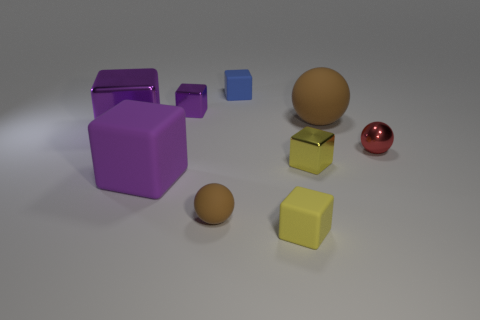What is the color of the metal ball?
Offer a very short reply. Red. There is a small block that is the same color as the big metallic thing; what is it made of?
Ensure brevity in your answer.  Metal. What is the material of the thing that is on the right side of the big matte ball?
Keep it short and to the point. Metal. What size is the other rubber sphere that is the same color as the tiny rubber sphere?
Your response must be concise. Large. Are there any cyan metal cubes that have the same size as the blue object?
Make the answer very short. No. Do the small blue object and the brown rubber object that is behind the big purple matte cube have the same shape?
Provide a succinct answer. No. There is a purple shiny thing that is in front of the small purple cube; does it have the same size as the brown matte sphere in front of the red metal thing?
Keep it short and to the point. No. What number of other objects are the same shape as the large brown rubber thing?
Ensure brevity in your answer.  2. There is a blue cube to the right of the purple thing that is behind the large brown matte thing; what is it made of?
Give a very brief answer. Rubber. What number of metallic things are tiny objects or tiny cyan blocks?
Ensure brevity in your answer.  3. 